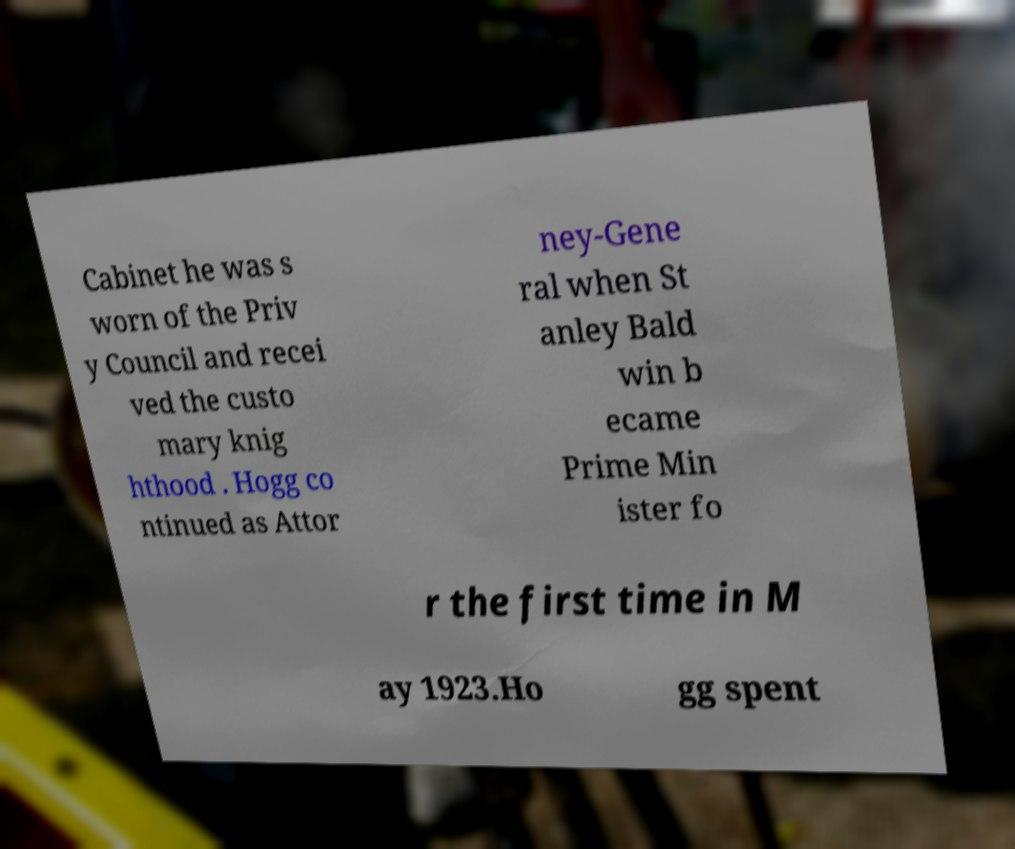What messages or text are displayed in this image? I need them in a readable, typed format. Cabinet he was s worn of the Priv y Council and recei ved the custo mary knig hthood . Hogg co ntinued as Attor ney-Gene ral when St anley Bald win b ecame Prime Min ister fo r the first time in M ay 1923.Ho gg spent 